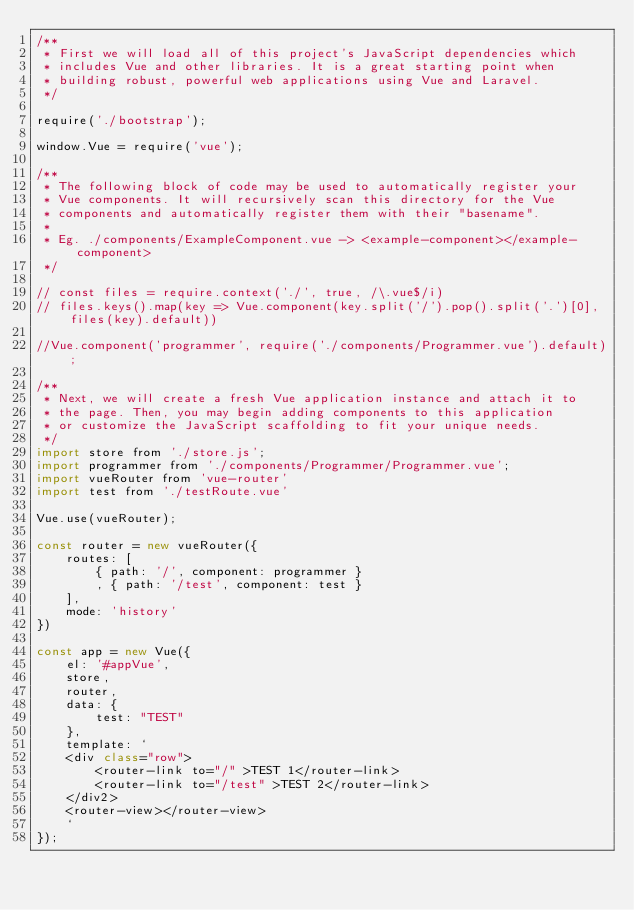<code> <loc_0><loc_0><loc_500><loc_500><_JavaScript_>/**
 * First we will load all of this project's JavaScript dependencies which
 * includes Vue and other libraries. It is a great starting point when
 * building robust, powerful web applications using Vue and Laravel.
 */

require('./bootstrap');

window.Vue = require('vue');

/**
 * The following block of code may be used to automatically register your
 * Vue components. It will recursively scan this directory for the Vue
 * components and automatically register them with their "basename".
 *
 * Eg. ./components/ExampleComponent.vue -> <example-component></example-component>
 */

// const files = require.context('./', true, /\.vue$/i)
// files.keys().map(key => Vue.component(key.split('/').pop().split('.')[0], files(key).default))

//Vue.component('programmer', require('./components/Programmer.vue').default);

/**
 * Next, we will create a fresh Vue application instance and attach it to
 * the page. Then, you may begin adding components to this application
 * or customize the JavaScript scaffolding to fit your unique needs.
 */
import store from './store.js';
import programmer from './components/Programmer/Programmer.vue';
import vueRouter from 'vue-router'
import test from './testRoute.vue'

Vue.use(vueRouter);

const router = new vueRouter({
    routes: [
        { path: '/', component: programmer }
        , { path: '/test', component: test }
    ],
    mode: 'history'
})

const app = new Vue({
    el: '#appVue',
    store,
    router,
    data: {
        test: "TEST"
    },
    template: `
    <div class="row">
        <router-link to="/" >TEST 1</router-link>
        <router-link to="/test" >TEST 2</router-link>
    </div2>
    <router-view></router-view>
    `
});





</code> 